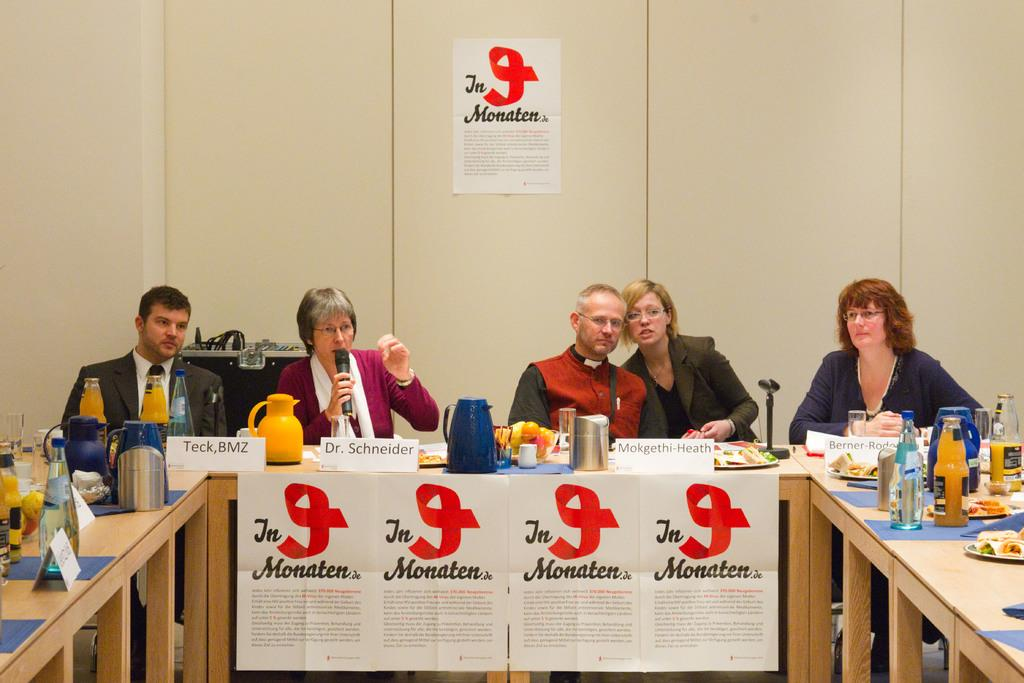What are the people in the image doing? The people in the image are seated on chairs. What is the woman holding in the image? The woman is holding a microphone in the image. What is the woman doing with the microphone? The woman is speaking in the image. image. What objects can be seen on the table in the image? There are flasks or glasses on a table in the image. What type of cloth is being used to cover the payment area in the image? There is no cloth or payment area present in the image. 